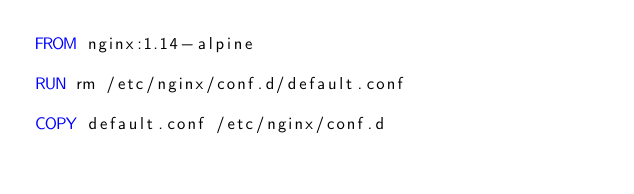<code> <loc_0><loc_0><loc_500><loc_500><_Dockerfile_>FROM nginx:1.14-alpine

RUN rm /etc/nginx/conf.d/default.conf

COPY default.conf /etc/nginx/conf.d
</code> 